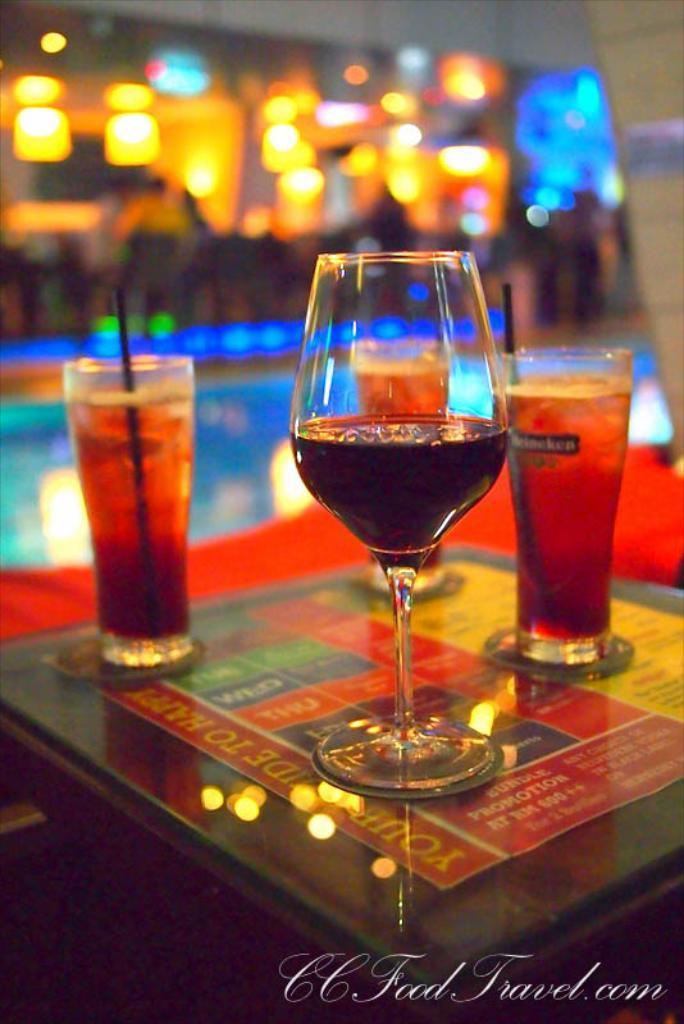Can you describe this image briefly? In this image I can see few glasses and I can see the liquid in it, background I can see few lights. 